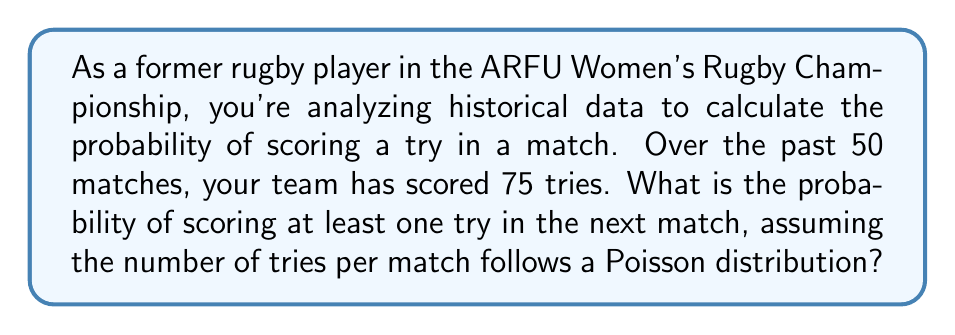Could you help me with this problem? Let's approach this step-by-step:

1) First, we need to calculate the average number of tries per match (λ):
   $$ \lambda = \frac{\text{Total tries}}{\text{Total matches}} = \frac{75}{50} = 1.5 $$

2) We're using a Poisson distribution, where the probability of x events occurring is given by:
   $$ P(X=x) = \frac{e^{-\lambda}\lambda^x}{x!} $$

3) We want the probability of scoring at least one try, which is the same as 1 minus the probability of scoring zero tries:
   $$ P(\text{at least one try}) = 1 - P(X=0) $$

4) Let's calculate P(X=0):
   $$ P(X=0) = \frac{e^{-1.5}(1.5)^0}{0!} = e^{-1.5} \approx 0.2231 $$

5) Therefore, the probability of scoring at least one try is:
   $$ P(\text{at least one try}) = 1 - 0.2231 = 0.7769 $$

6) Convert to a percentage:
   $$ 0.7769 \times 100\% = 77.69\% $$
Answer: 77.69% 